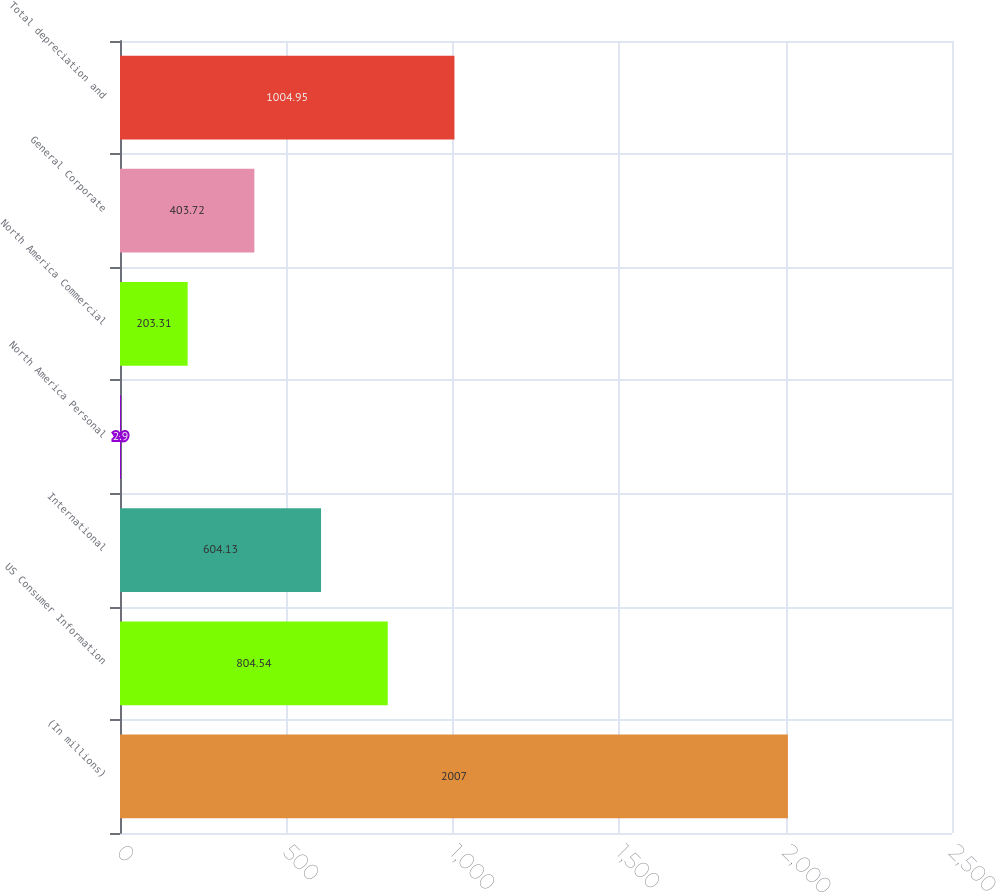Convert chart. <chart><loc_0><loc_0><loc_500><loc_500><bar_chart><fcel>(In millions)<fcel>US Consumer Information<fcel>International<fcel>North America Personal<fcel>North America Commercial<fcel>General Corporate<fcel>Total depreciation and<nl><fcel>2007<fcel>804.54<fcel>604.13<fcel>2.9<fcel>203.31<fcel>403.72<fcel>1004.95<nl></chart> 